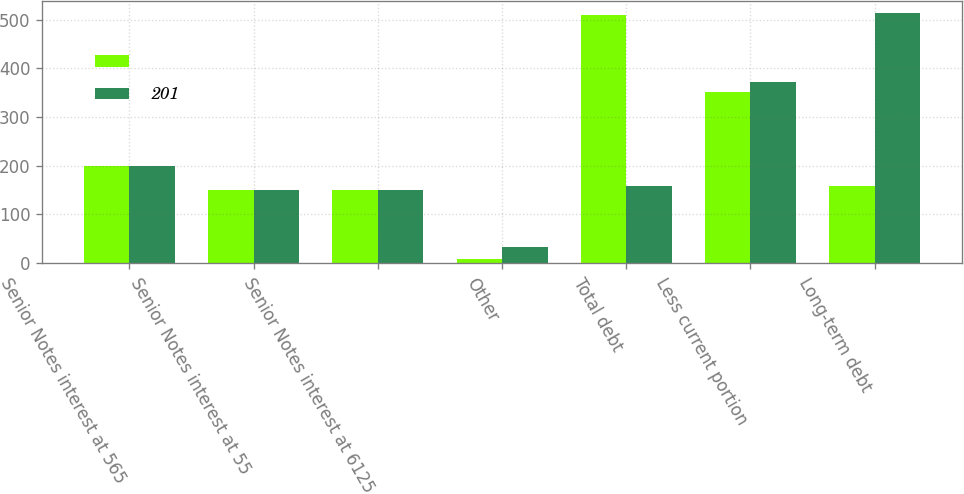Convert chart to OTSL. <chart><loc_0><loc_0><loc_500><loc_500><stacked_bar_chart><ecel><fcel>Senior Notes interest at 565<fcel>Senior Notes interest at 55<fcel>Senior Notes interest at 6125<fcel>Other<fcel>Total debt<fcel>Less current portion<fcel>Long-term debt<nl><fcel><fcel>200<fcel>150<fcel>151<fcel>9<fcel>510<fcel>351<fcel>159<nl><fcel>201<fcel>200<fcel>151<fcel>151<fcel>34<fcel>159<fcel>373<fcel>514<nl></chart> 